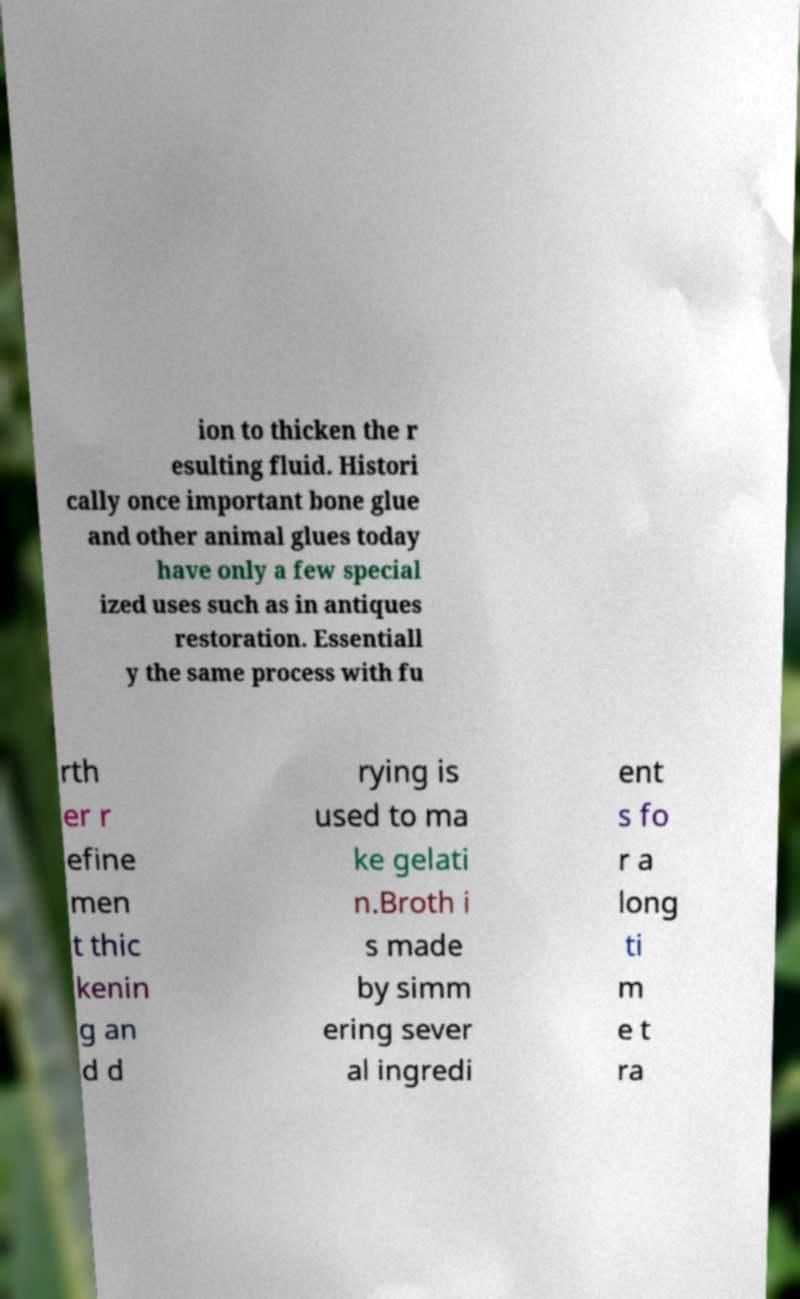Please identify and transcribe the text found in this image. ion to thicken the r esulting fluid. Histori cally once important bone glue and other animal glues today have only a few special ized uses such as in antiques restoration. Essentiall y the same process with fu rth er r efine men t thic kenin g an d d rying is used to ma ke gelati n.Broth i s made by simm ering sever al ingredi ent s fo r a long ti m e t ra 